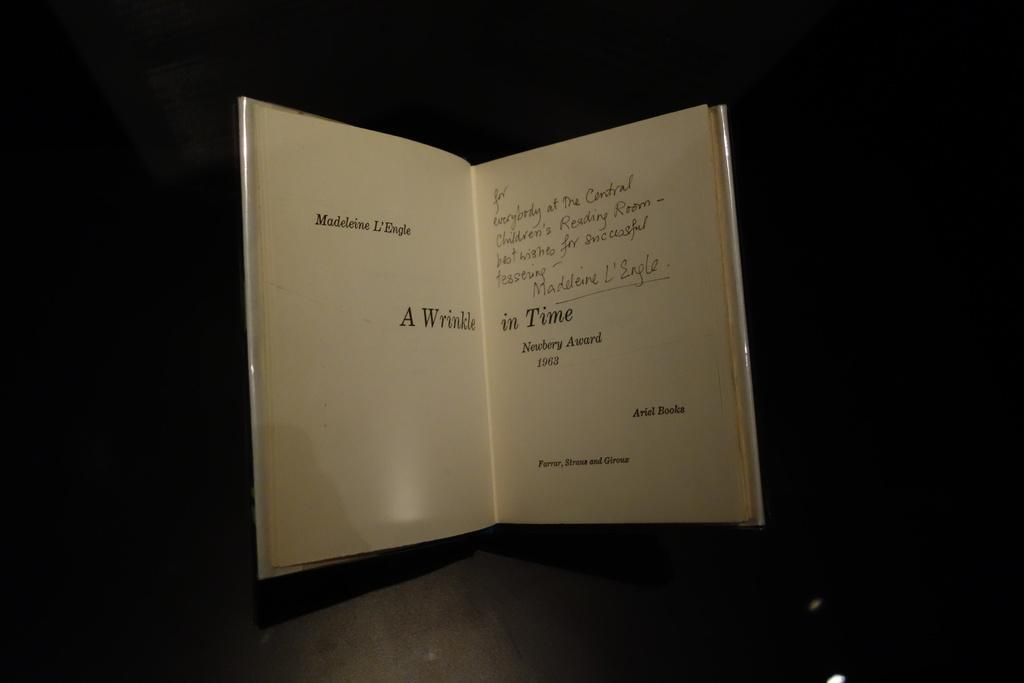<image>
Present a compact description of the photo's key features. A book titled A Wrinkle in Time is open and signed on the inside. 